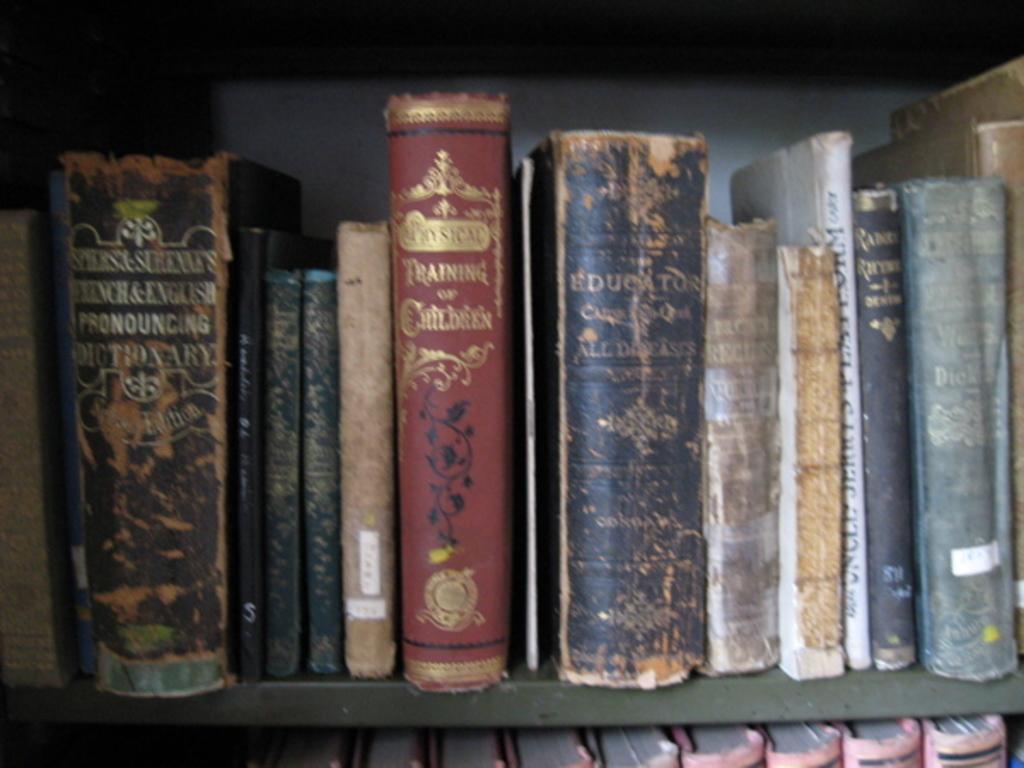In one or two sentences, can you explain what this image depicts? In this image we can see a group of books placed in the shelves. 